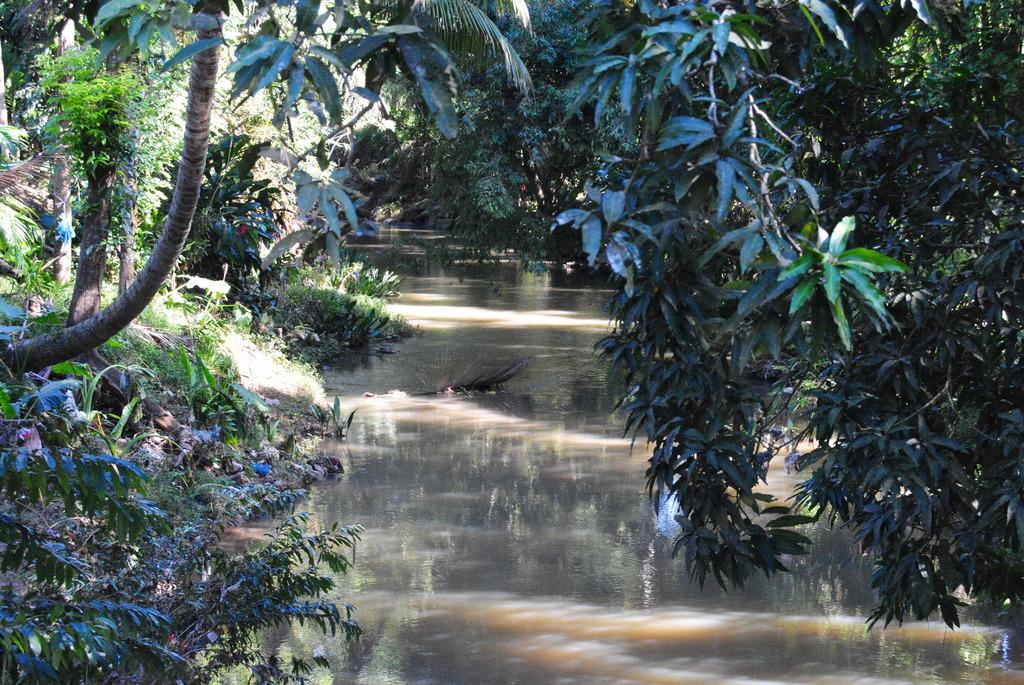What is visible in the image? Water is visible in the image. What type of vegetation can be seen in the image? There are plants and trees in the image. Can you see any maids or fairies interacting with the plants in the image? There is no indication of any maids or fairies present in the image. Is there a yak visible in the image? There is no yak present in the image. 